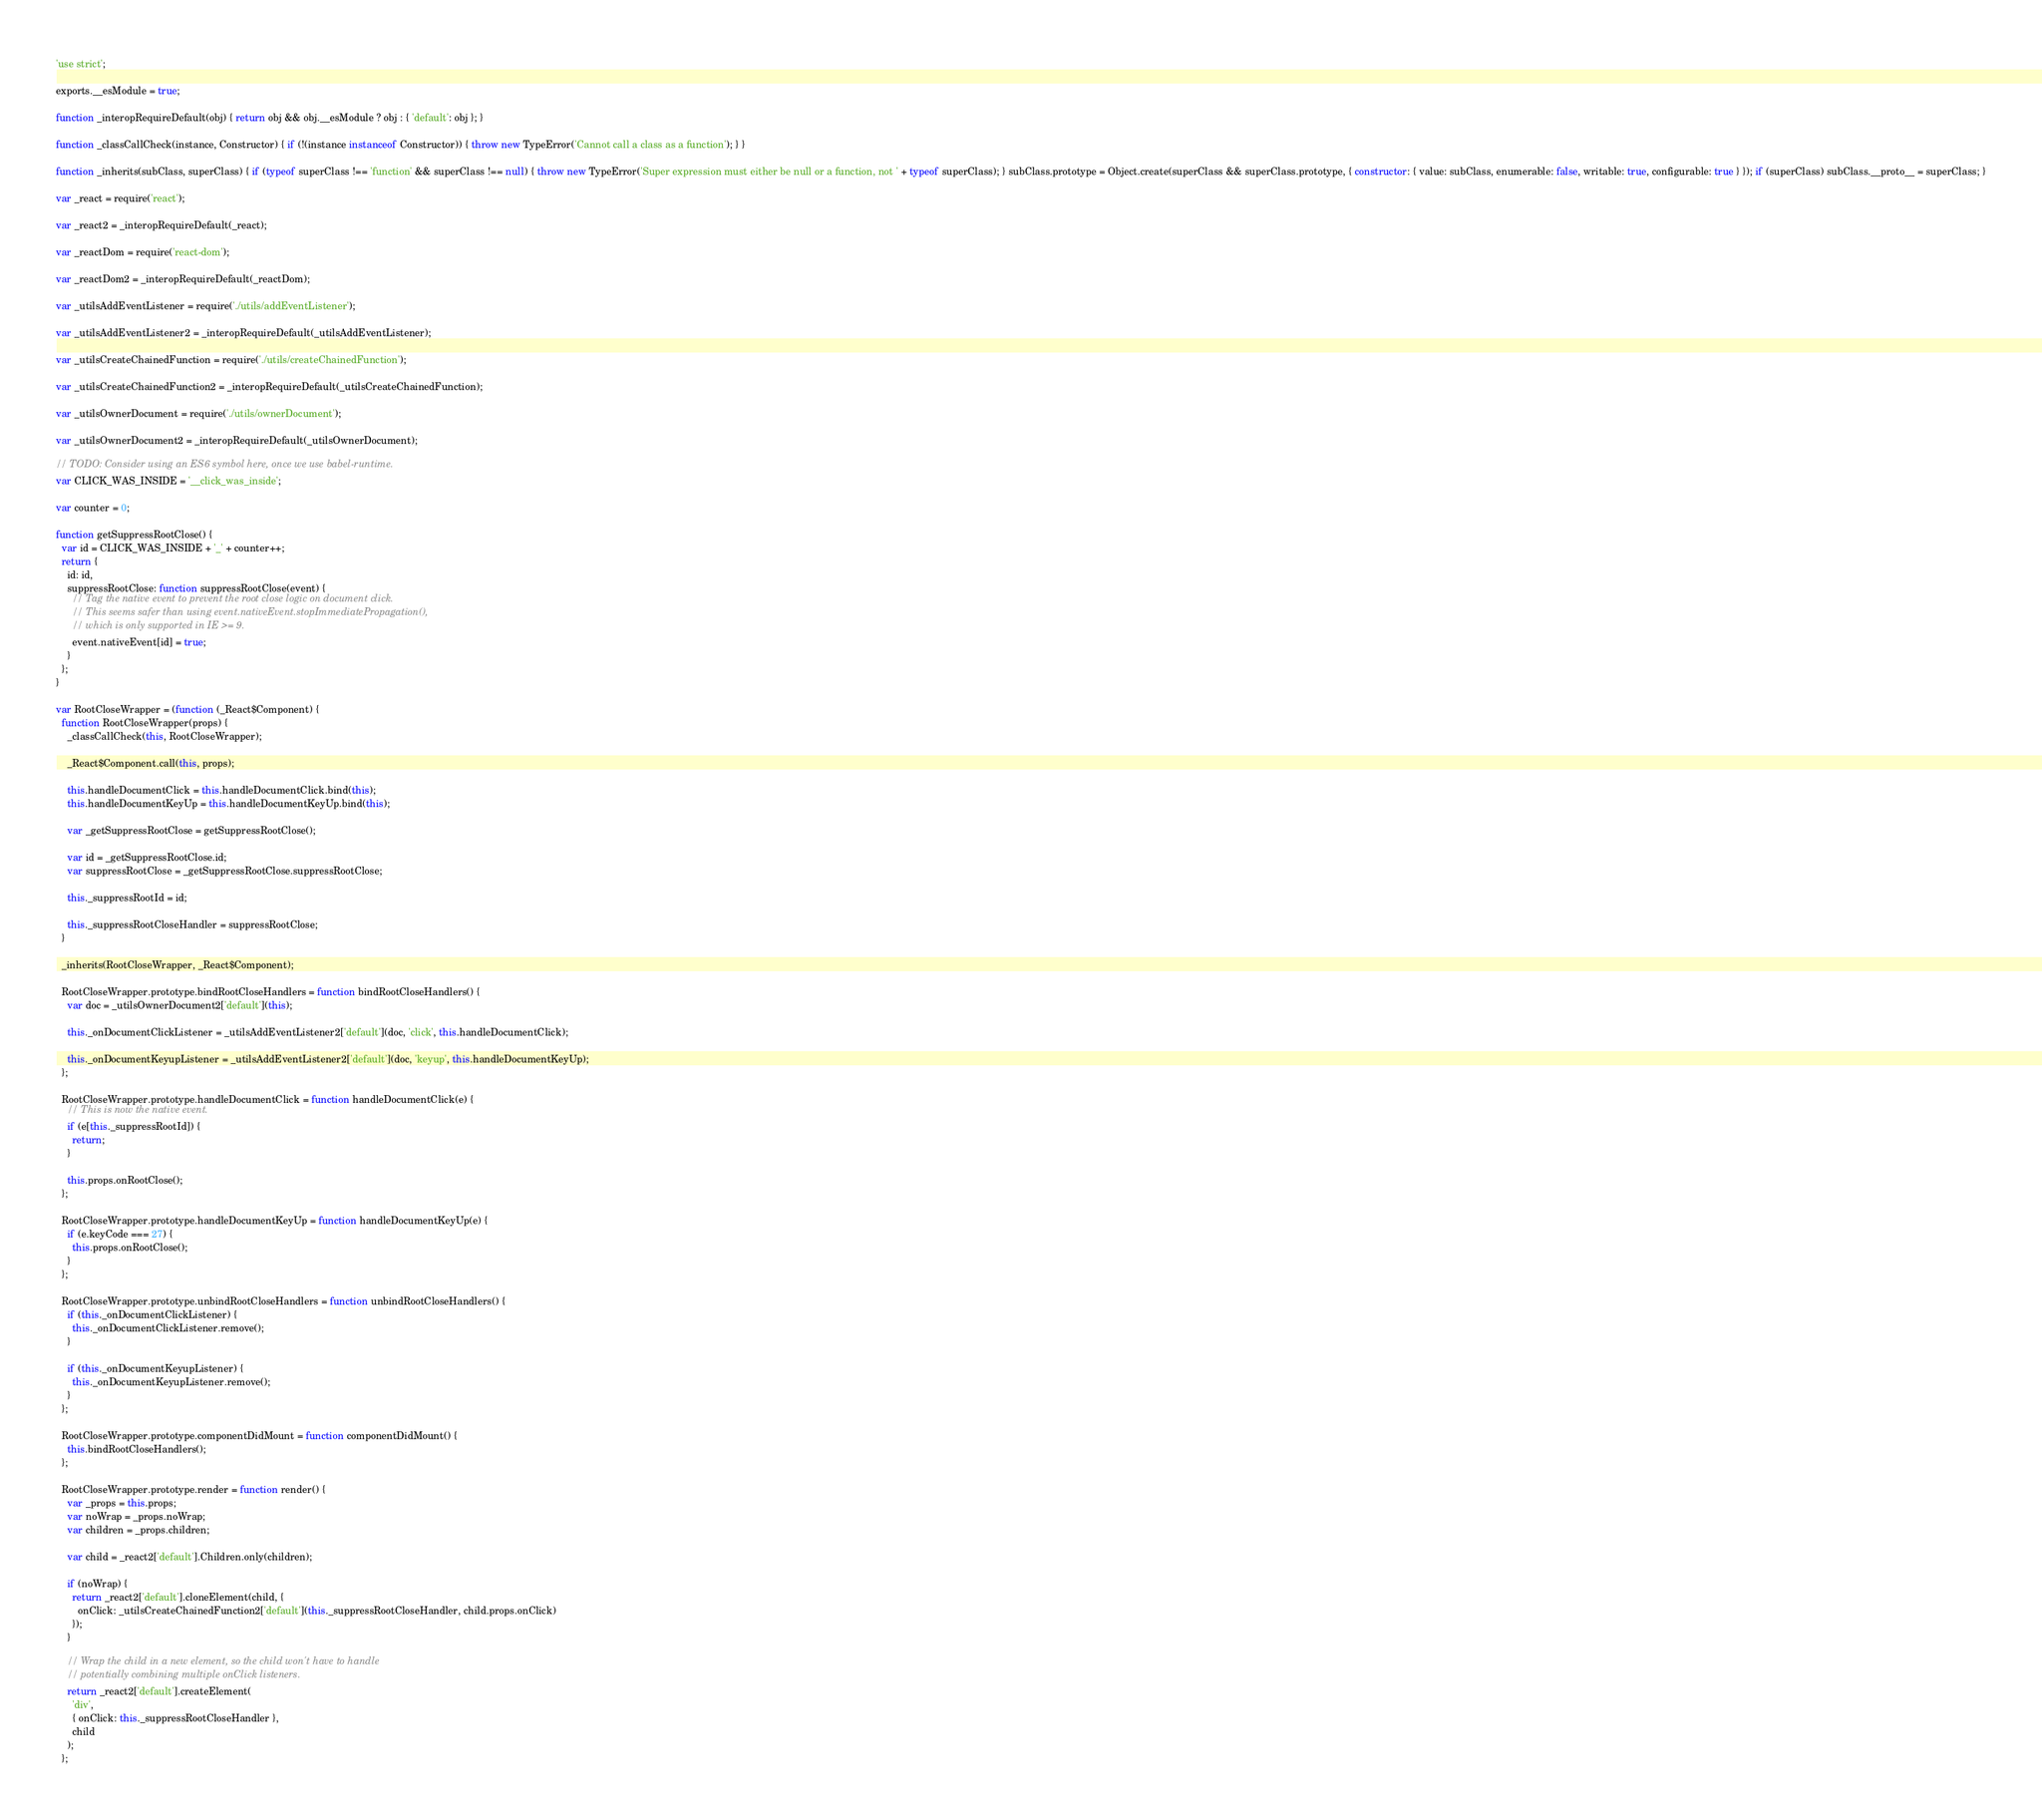Convert code to text. <code><loc_0><loc_0><loc_500><loc_500><_JavaScript_>'use strict';

exports.__esModule = true;

function _interopRequireDefault(obj) { return obj && obj.__esModule ? obj : { 'default': obj }; }

function _classCallCheck(instance, Constructor) { if (!(instance instanceof Constructor)) { throw new TypeError('Cannot call a class as a function'); } }

function _inherits(subClass, superClass) { if (typeof superClass !== 'function' && superClass !== null) { throw new TypeError('Super expression must either be null or a function, not ' + typeof superClass); } subClass.prototype = Object.create(superClass && superClass.prototype, { constructor: { value: subClass, enumerable: false, writable: true, configurable: true } }); if (superClass) subClass.__proto__ = superClass; }

var _react = require('react');

var _react2 = _interopRequireDefault(_react);

var _reactDom = require('react-dom');

var _reactDom2 = _interopRequireDefault(_reactDom);

var _utilsAddEventListener = require('./utils/addEventListener');

var _utilsAddEventListener2 = _interopRequireDefault(_utilsAddEventListener);

var _utilsCreateChainedFunction = require('./utils/createChainedFunction');

var _utilsCreateChainedFunction2 = _interopRequireDefault(_utilsCreateChainedFunction);

var _utilsOwnerDocument = require('./utils/ownerDocument');

var _utilsOwnerDocument2 = _interopRequireDefault(_utilsOwnerDocument);

// TODO: Consider using an ES6 symbol here, once we use babel-runtime.
var CLICK_WAS_INSIDE = '__click_was_inside';

var counter = 0;

function getSuppressRootClose() {
  var id = CLICK_WAS_INSIDE + '_' + counter++;
  return {
    id: id,
    suppressRootClose: function suppressRootClose(event) {
      // Tag the native event to prevent the root close logic on document click.
      // This seems safer than using event.nativeEvent.stopImmediatePropagation(),
      // which is only supported in IE >= 9.
      event.nativeEvent[id] = true;
    }
  };
}

var RootCloseWrapper = (function (_React$Component) {
  function RootCloseWrapper(props) {
    _classCallCheck(this, RootCloseWrapper);

    _React$Component.call(this, props);

    this.handleDocumentClick = this.handleDocumentClick.bind(this);
    this.handleDocumentKeyUp = this.handleDocumentKeyUp.bind(this);

    var _getSuppressRootClose = getSuppressRootClose();

    var id = _getSuppressRootClose.id;
    var suppressRootClose = _getSuppressRootClose.suppressRootClose;

    this._suppressRootId = id;

    this._suppressRootCloseHandler = suppressRootClose;
  }

  _inherits(RootCloseWrapper, _React$Component);

  RootCloseWrapper.prototype.bindRootCloseHandlers = function bindRootCloseHandlers() {
    var doc = _utilsOwnerDocument2['default'](this);

    this._onDocumentClickListener = _utilsAddEventListener2['default'](doc, 'click', this.handleDocumentClick);

    this._onDocumentKeyupListener = _utilsAddEventListener2['default'](doc, 'keyup', this.handleDocumentKeyUp);
  };

  RootCloseWrapper.prototype.handleDocumentClick = function handleDocumentClick(e) {
    // This is now the native event.
    if (e[this._suppressRootId]) {
      return;
    }

    this.props.onRootClose();
  };

  RootCloseWrapper.prototype.handleDocumentKeyUp = function handleDocumentKeyUp(e) {
    if (e.keyCode === 27) {
      this.props.onRootClose();
    }
  };

  RootCloseWrapper.prototype.unbindRootCloseHandlers = function unbindRootCloseHandlers() {
    if (this._onDocumentClickListener) {
      this._onDocumentClickListener.remove();
    }

    if (this._onDocumentKeyupListener) {
      this._onDocumentKeyupListener.remove();
    }
  };

  RootCloseWrapper.prototype.componentDidMount = function componentDidMount() {
    this.bindRootCloseHandlers();
  };

  RootCloseWrapper.prototype.render = function render() {
    var _props = this.props;
    var noWrap = _props.noWrap;
    var children = _props.children;

    var child = _react2['default'].Children.only(children);

    if (noWrap) {
      return _react2['default'].cloneElement(child, {
        onClick: _utilsCreateChainedFunction2['default'](this._suppressRootCloseHandler, child.props.onClick)
      });
    }

    // Wrap the child in a new element, so the child won't have to handle
    // potentially combining multiple onClick listeners.
    return _react2['default'].createElement(
      'div',
      { onClick: this._suppressRootCloseHandler },
      child
    );
  };
</code> 